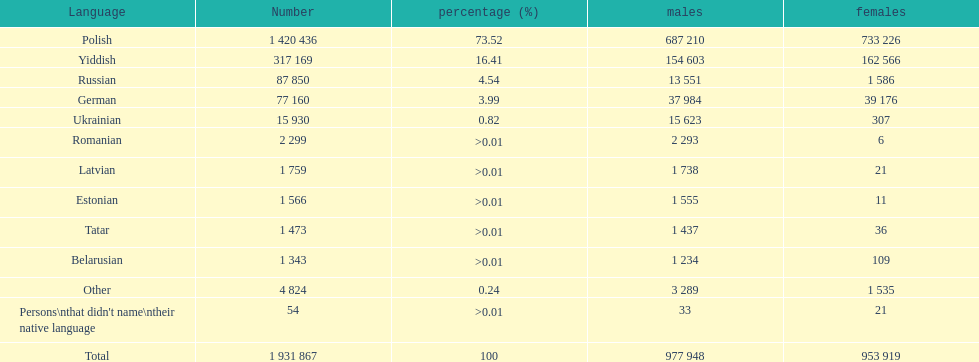What was the leading language among those with a percentage greater than Romanian. 